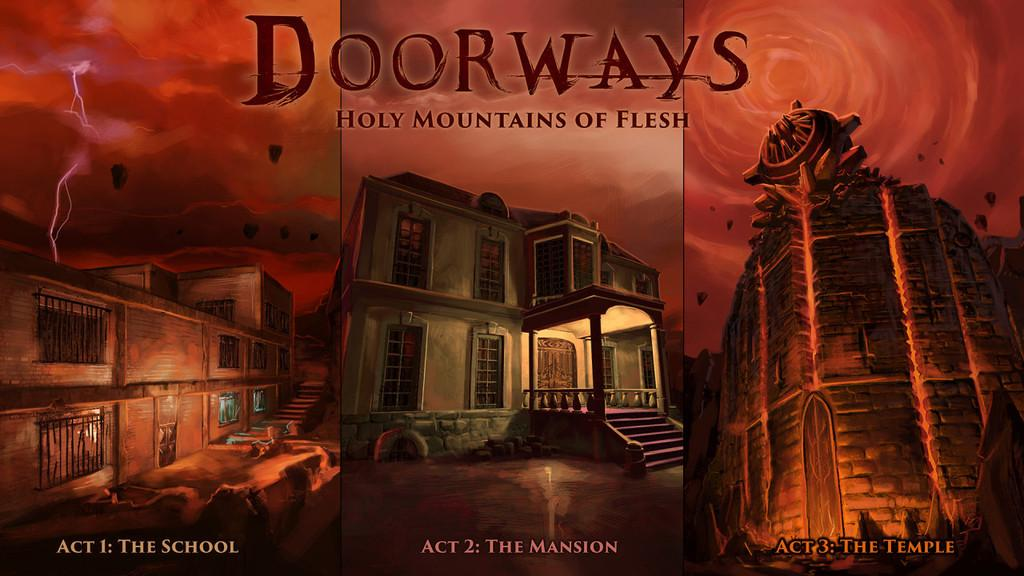<image>
Describe the image concisely. a poster for Doorways Holy Mountains of Flesh 